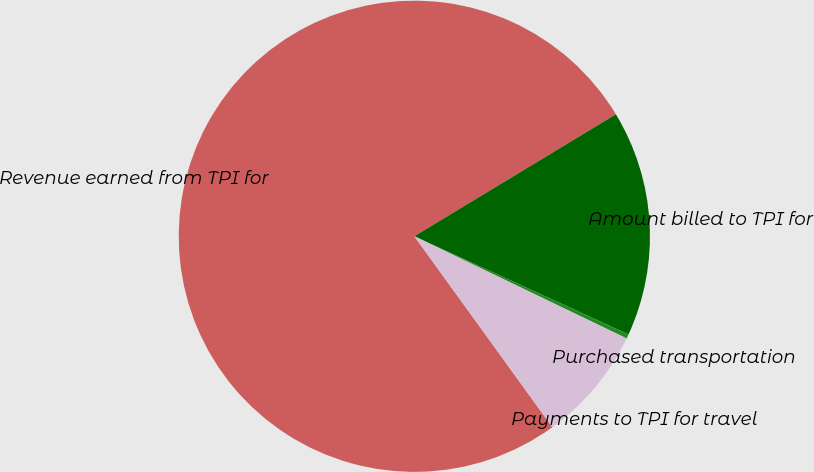Convert chart to OTSL. <chart><loc_0><loc_0><loc_500><loc_500><pie_chart><fcel>Revenue earned from TPI for<fcel>Amount billed to TPI for<fcel>Purchased transportation<fcel>Payments to TPI for travel<nl><fcel>76.3%<fcel>15.5%<fcel>0.3%<fcel>7.9%<nl></chart> 